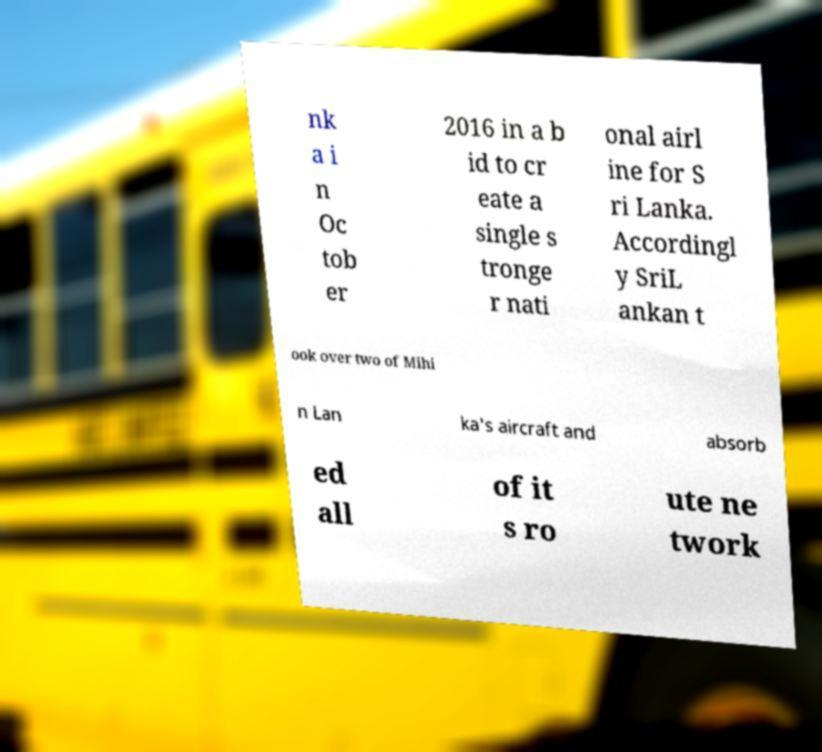Please identify and transcribe the text found in this image. nk a i n Oc tob er 2016 in a b id to cr eate a single s tronge r nati onal airl ine for S ri Lanka. Accordingl y SriL ankan t ook over two of Mihi n Lan ka's aircraft and absorb ed all of it s ro ute ne twork 